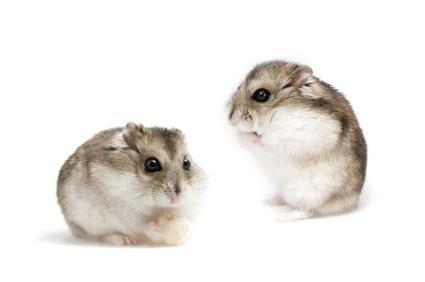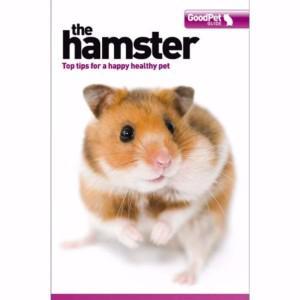The first image is the image on the left, the second image is the image on the right. Considering the images on both sides, is "In one of the images there are two hamsters." valid? Answer yes or no. Yes. 